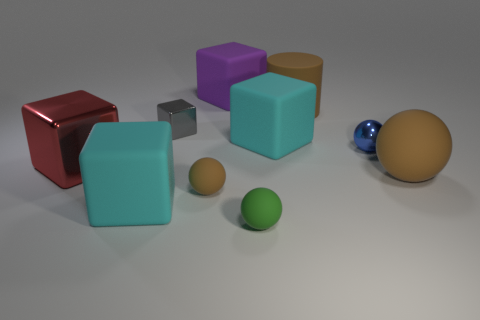What is the material of the large red object?
Ensure brevity in your answer.  Metal. There is a tiny rubber object that is the same color as the large sphere; what shape is it?
Provide a short and direct response. Sphere. What number of brown balls have the same size as the green rubber ball?
Your answer should be compact. 1. What number of things are either large cubes that are behind the large brown cylinder or large rubber objects that are behind the blue thing?
Keep it short and to the point. 3. Is the material of the big cyan cube in front of the red thing the same as the small block that is behind the large red shiny thing?
Offer a terse response. No. There is a large cyan matte thing that is to the left of the tiny rubber thing behind the green matte thing; what is its shape?
Offer a terse response. Cube. Is there any other thing of the same color as the big cylinder?
Provide a short and direct response. Yes. There is a tiny ball in front of the rubber thing left of the gray shiny object; are there any large brown matte spheres on the left side of it?
Your answer should be very brief. No. Is the color of the small cube that is on the left side of the big purple rubber block the same as the large cube that is behind the small gray shiny thing?
Your response must be concise. No. There is a brown thing that is the same size as the blue shiny ball; what material is it?
Offer a terse response. Rubber. 